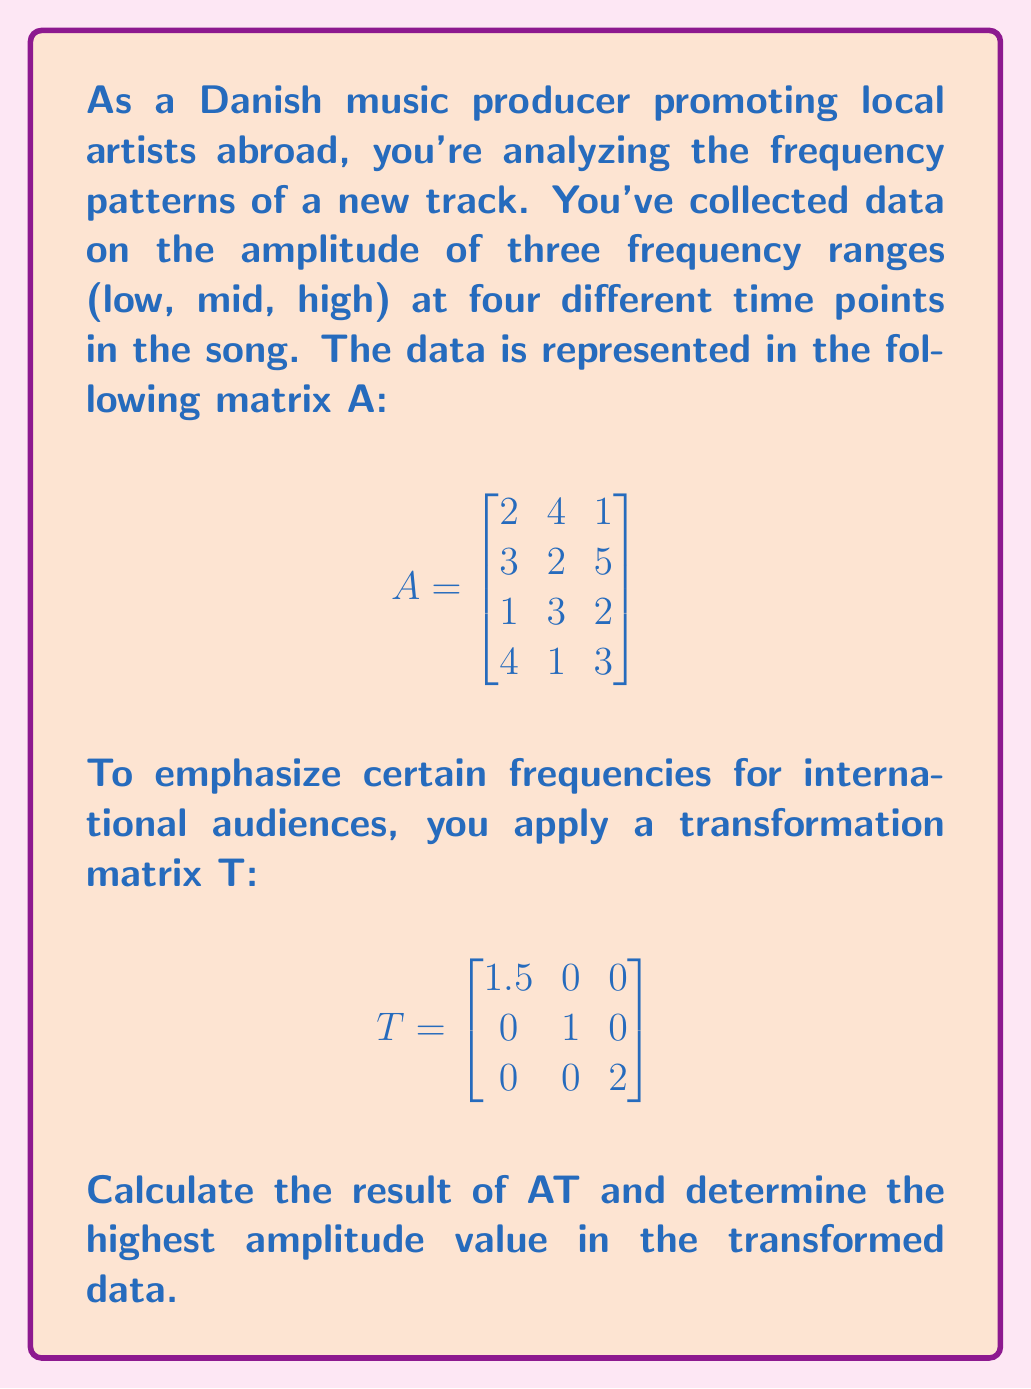Provide a solution to this math problem. To solve this problem, we need to follow these steps:

1) First, we need to perform matrix multiplication of A and T. The resulting matrix will have the same number of rows as A and the same number of columns as T.

2) The formula for matrix multiplication is:
   $$(AT)_{ij} = \sum_{k=1}^n A_{ik} \cdot T_{kj}$$

3) Let's calculate AT:

   $$AT = \begin{bmatrix}
   2(1.5) + 4(0) + 1(0) & 2(0) + 4(1) + 1(0) & 2(0) + 4(0) + 1(2) \\
   3(1.5) + 2(0) + 5(0) & 3(0) + 2(1) + 5(0) & 3(0) + 2(0) + 5(2) \\
   1(1.5) + 3(0) + 2(0) & 1(0) + 3(1) + 2(0) & 1(0) + 3(0) + 2(2) \\
   4(1.5) + 1(0) + 3(0) & 4(0) + 1(1) + 3(0) & 4(0) + 1(0) + 3(2)
   \end{bmatrix}$$

4) Simplifying:

   $$AT = \begin{bmatrix}
   3 & 4 & 2 \\
   4.5 & 2 & 10 \\
   1.5 & 3 & 4 \\
   6 & 1 & 6
   \end{bmatrix}$$

5) Now, we need to find the highest amplitude value in this transformed matrix. We can do this by comparing all the elements:

   $3, 4, 2, 4.5, 2, 10, 1.5, 3, 4, 6, 1, 6$

6) The highest value among these is 10.
Answer: 10 